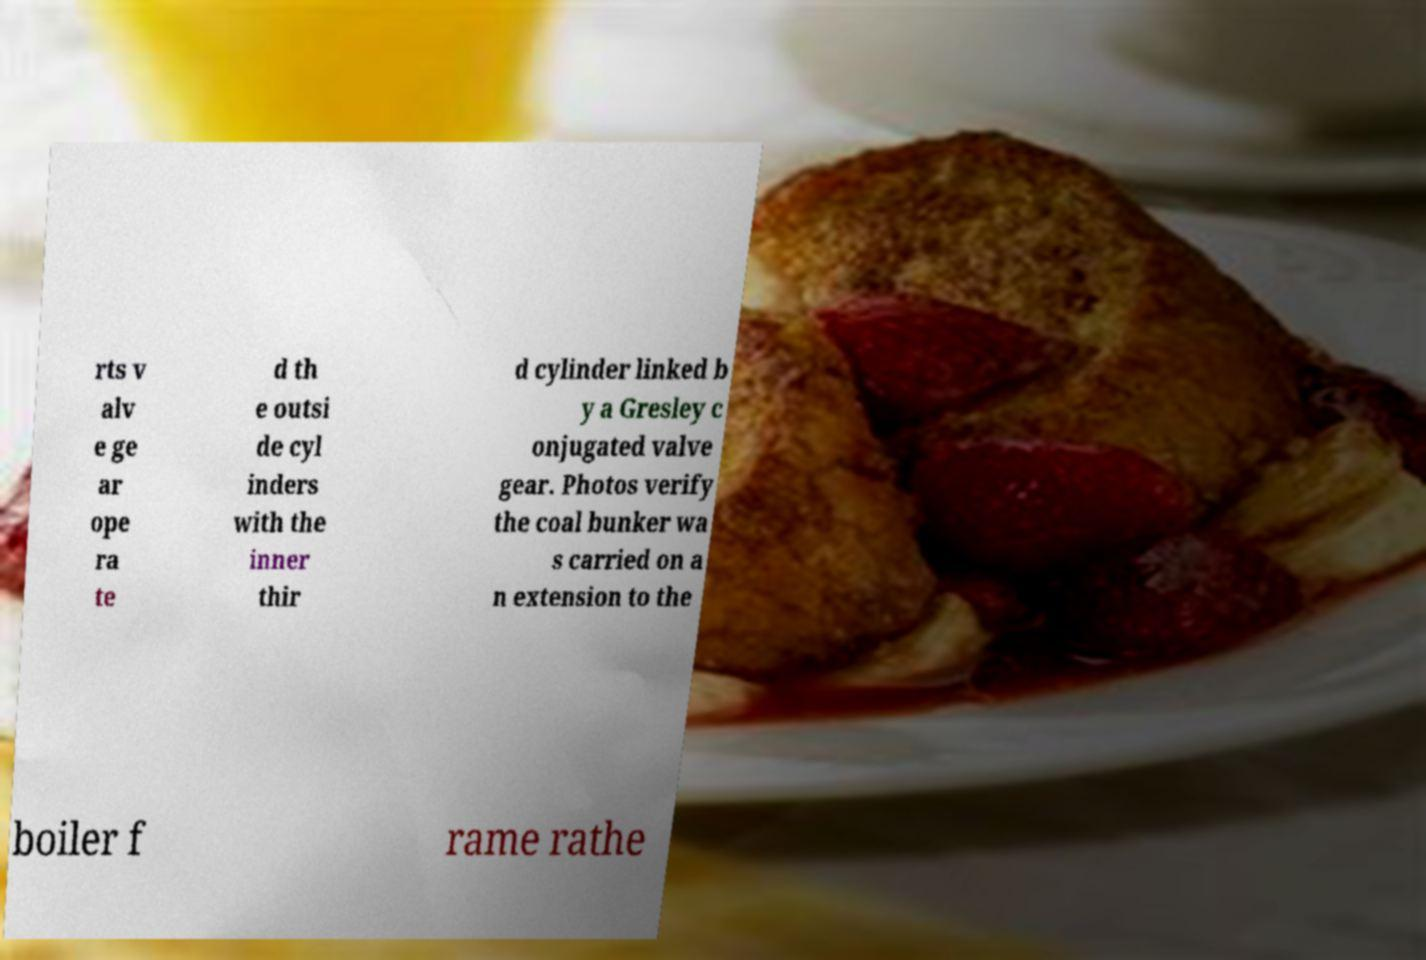Please read and relay the text visible in this image. What does it say? rts v alv e ge ar ope ra te d th e outsi de cyl inders with the inner thir d cylinder linked b y a Gresley c onjugated valve gear. Photos verify the coal bunker wa s carried on a n extension to the boiler f rame rathe 